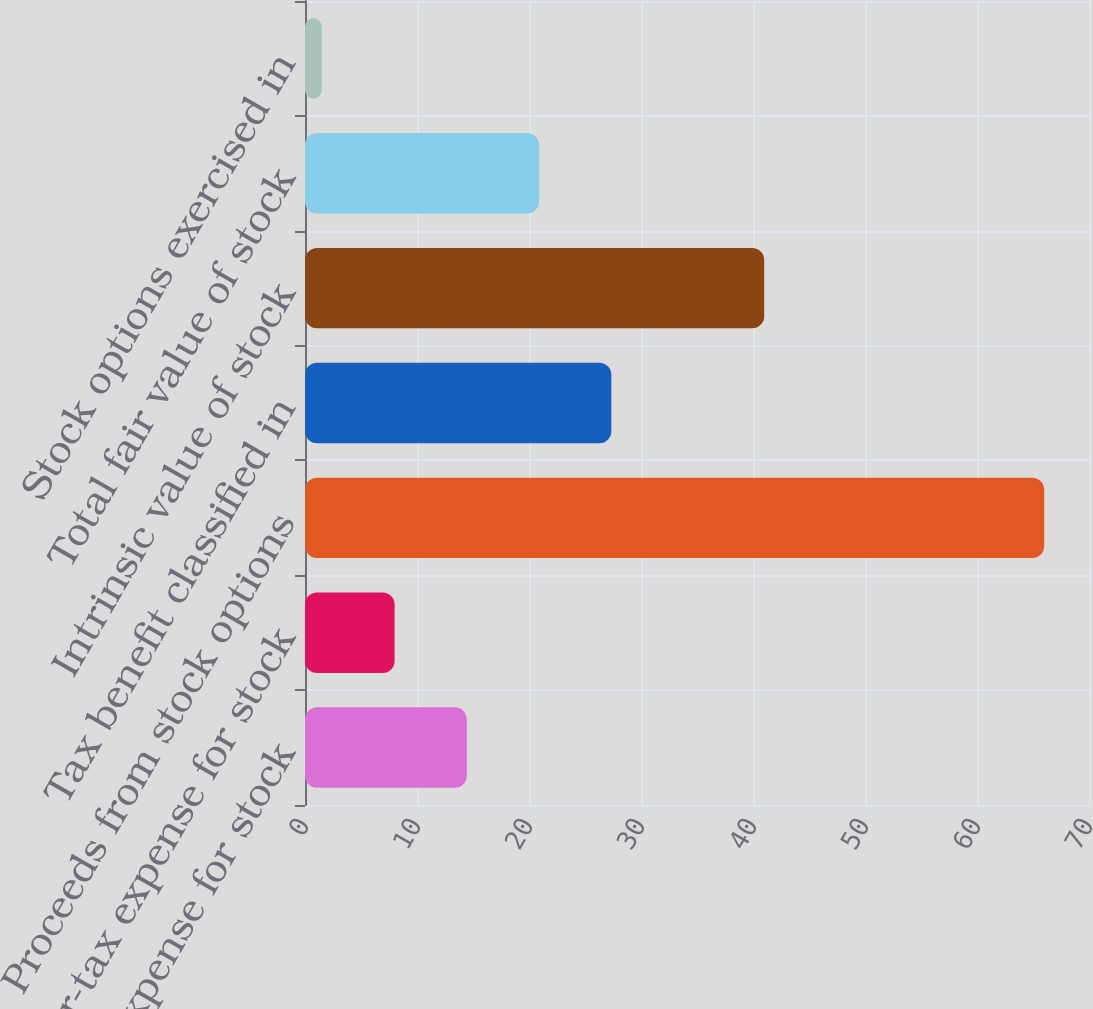Convert chart. <chart><loc_0><loc_0><loc_500><loc_500><bar_chart><fcel>Pretax expense for stock<fcel>After-tax expense for stock<fcel>Proceeds from stock options<fcel>Tax benefit classified in<fcel>Intrinsic value of stock<fcel>Total fair value of stock<fcel>Stock options exercised in<nl><fcel>14.45<fcel>8<fcel>66<fcel>27.35<fcel>41<fcel>20.9<fcel>1.5<nl></chart> 